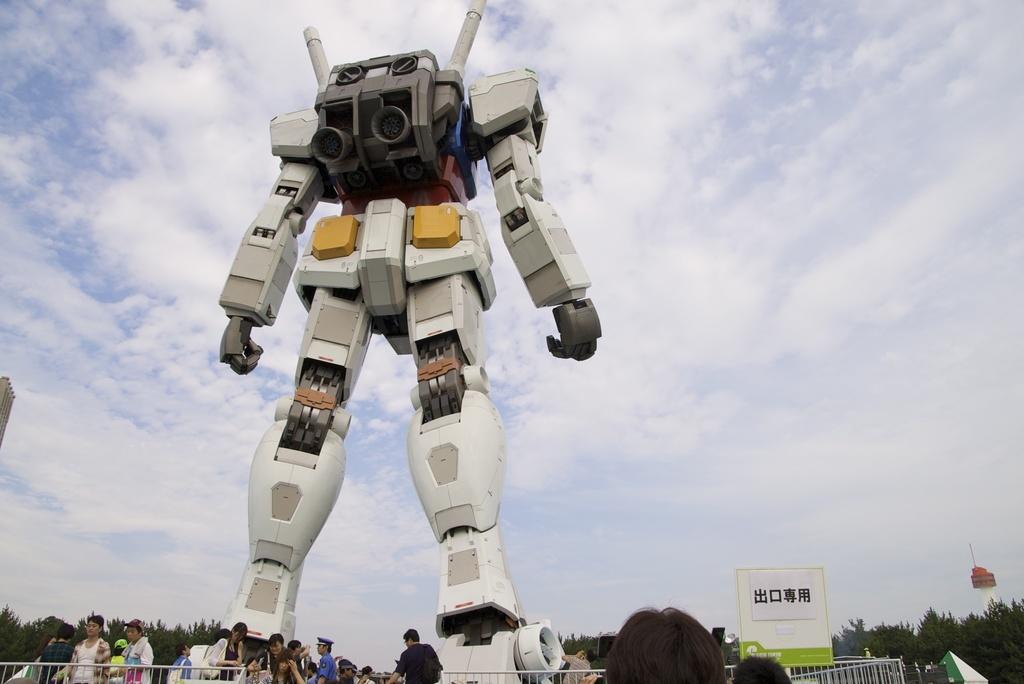Can you describe this image briefly? In this picture we can see a robot. There is a fence and a few people on the left side. There is a board, fence and a red object in the air. Sky is cloudy. 